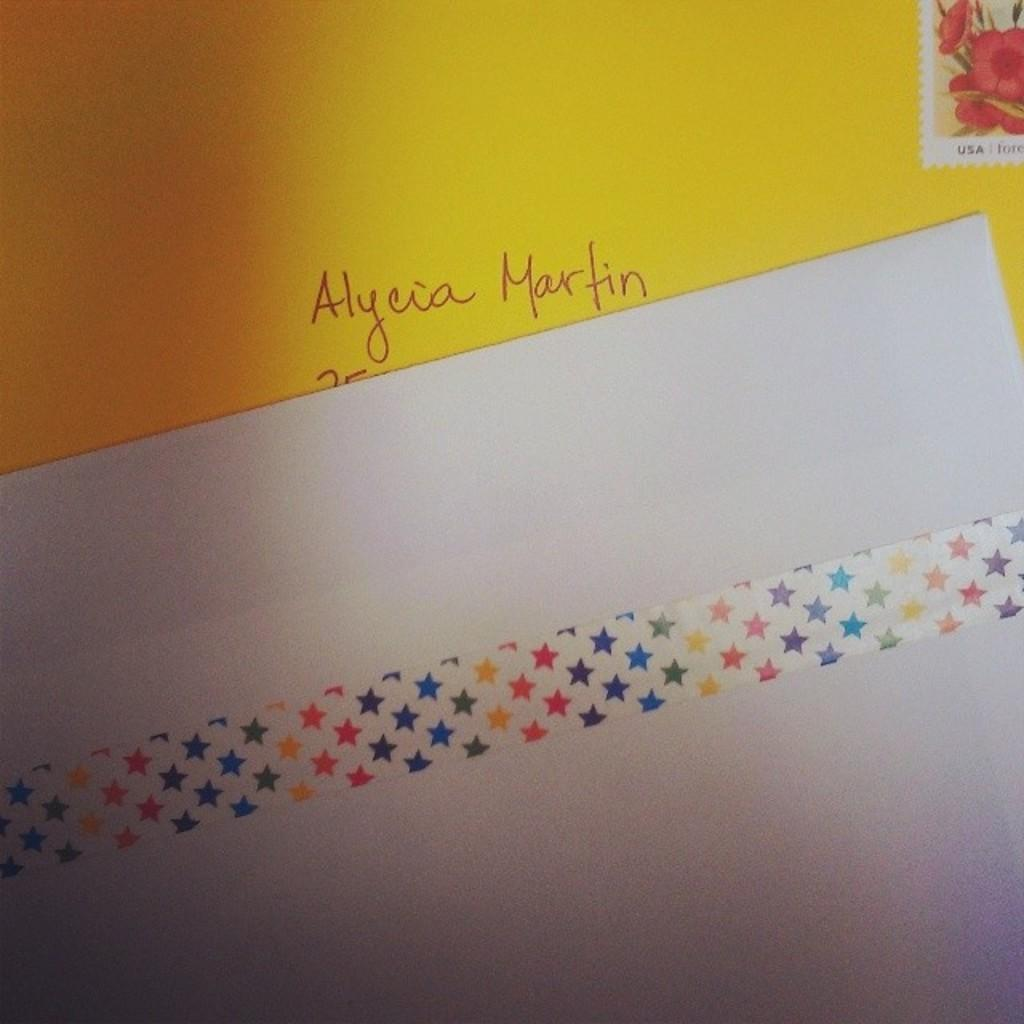Provide a one-sentence caption for the provided image. Envelope with the name Alycia Martin wrote on the front with a stamp. 